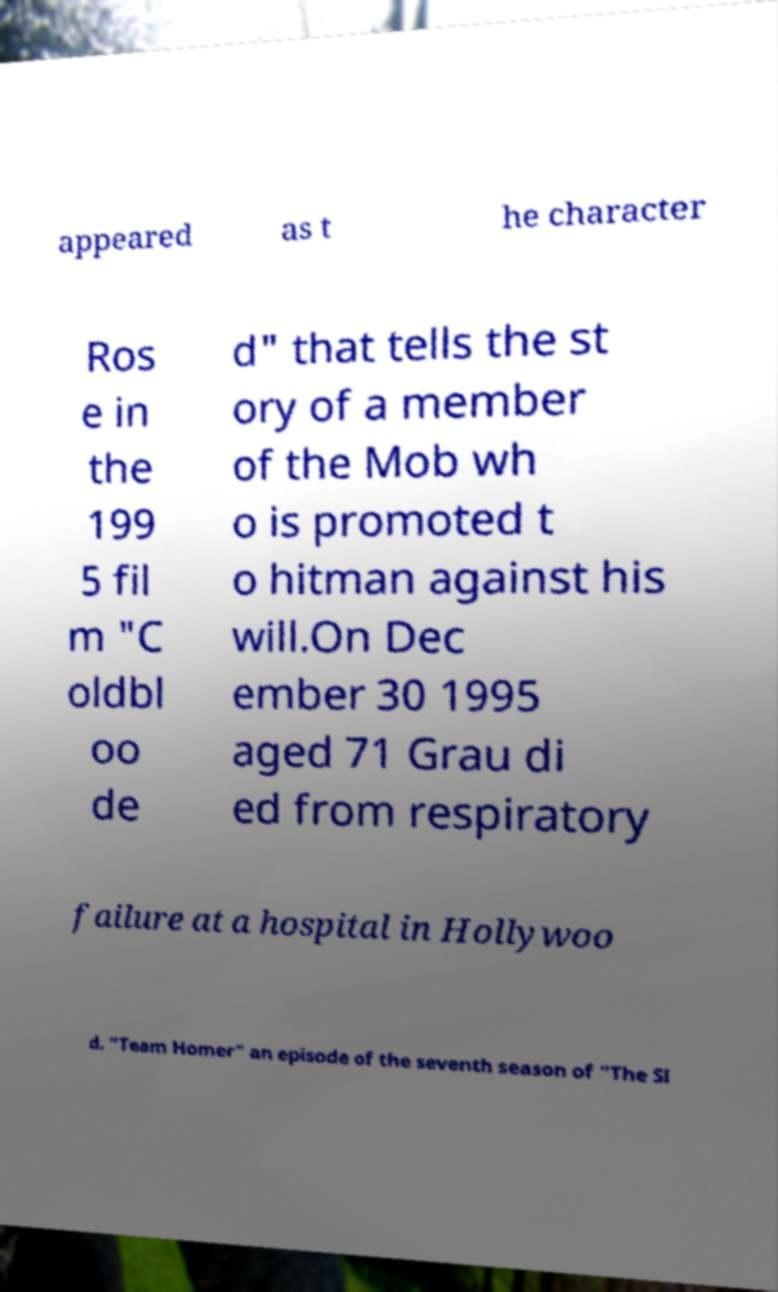Could you assist in decoding the text presented in this image and type it out clearly? appeared as t he character Ros e in the 199 5 fil m "C oldbl oo de d" that tells the st ory of a member of the Mob wh o is promoted t o hitman against his will.On Dec ember 30 1995 aged 71 Grau di ed from respiratory failure at a hospital in Hollywoo d. "Team Homer" an episode of the seventh season of "The Si 